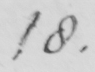What is written in this line of handwriting? 18 . 